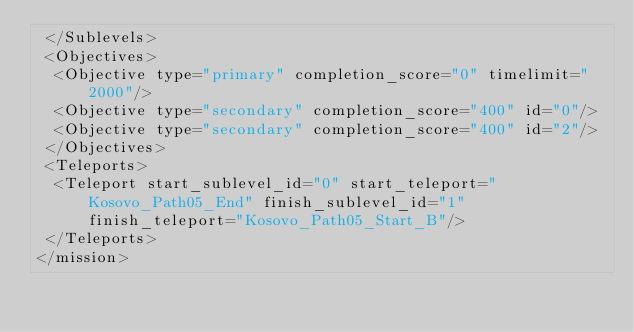<code> <loc_0><loc_0><loc_500><loc_500><_XML_> </Sublevels>
 <Objectives>
  <Objective type="primary" completion_score="0" timelimit="2000"/>
  <Objective type="secondary" completion_score="400" id="0"/>
  <Objective type="secondary" completion_score="400" id="2"/>
 </Objectives>
 <Teleports>
  <Teleport start_sublevel_id="0" start_teleport="Kosovo_Path05_End" finish_sublevel_id="1" finish_teleport="Kosovo_Path05_Start_B"/>
 </Teleports>
</mission></code> 